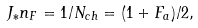<formula> <loc_0><loc_0><loc_500><loc_500>J _ { * } n _ { F } = 1 / N _ { c h } = ( 1 + F _ { a } ) / 2 ,</formula> 